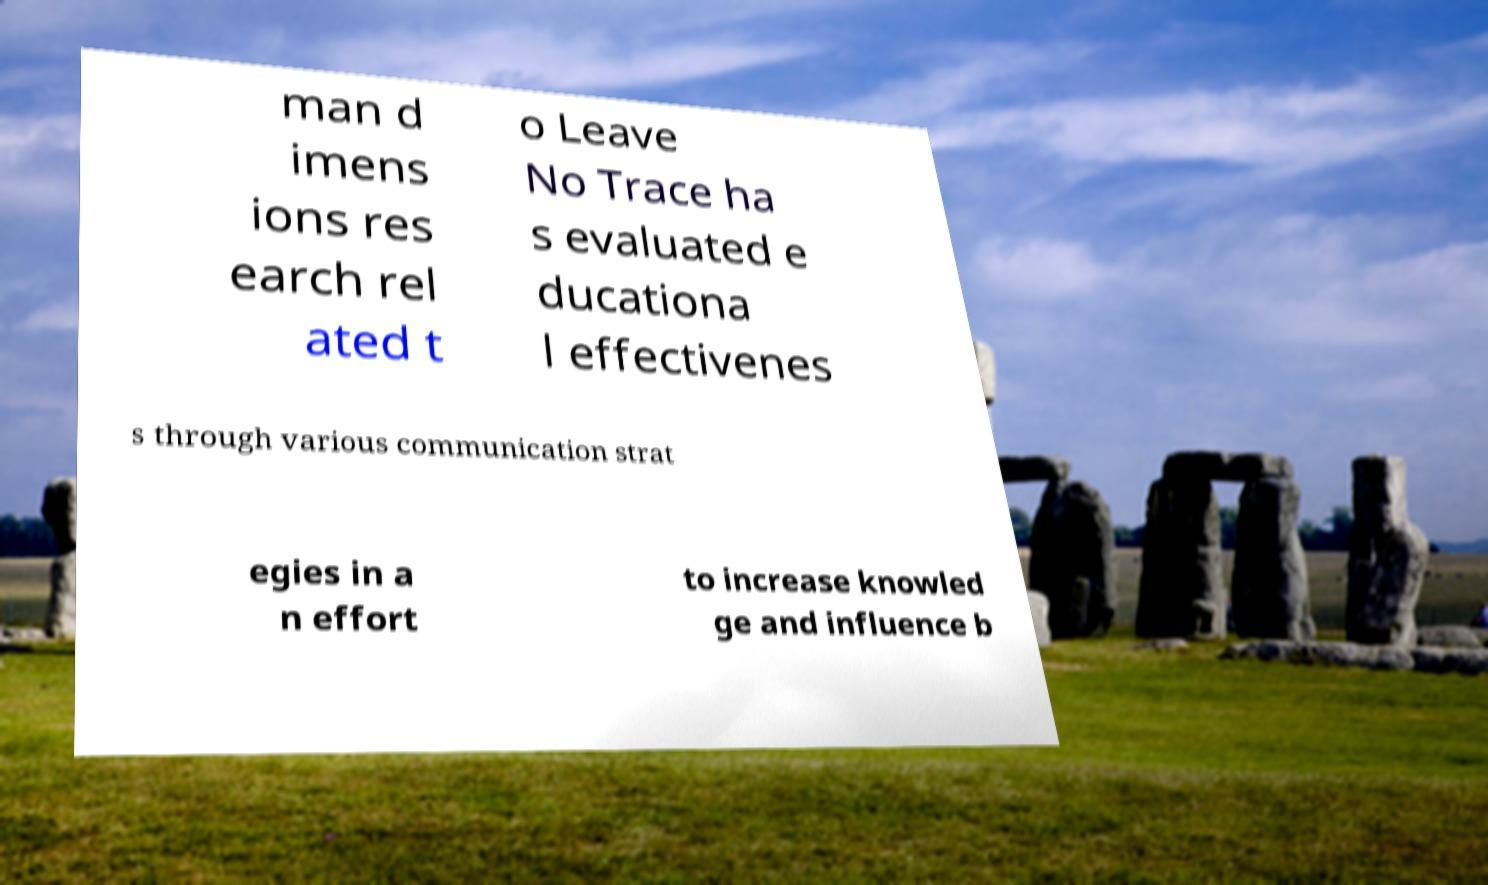What messages or text are displayed in this image? I need them in a readable, typed format. man d imens ions res earch rel ated t o Leave No Trace ha s evaluated e ducationa l effectivenes s through various communication strat egies in a n effort to increase knowled ge and influence b 